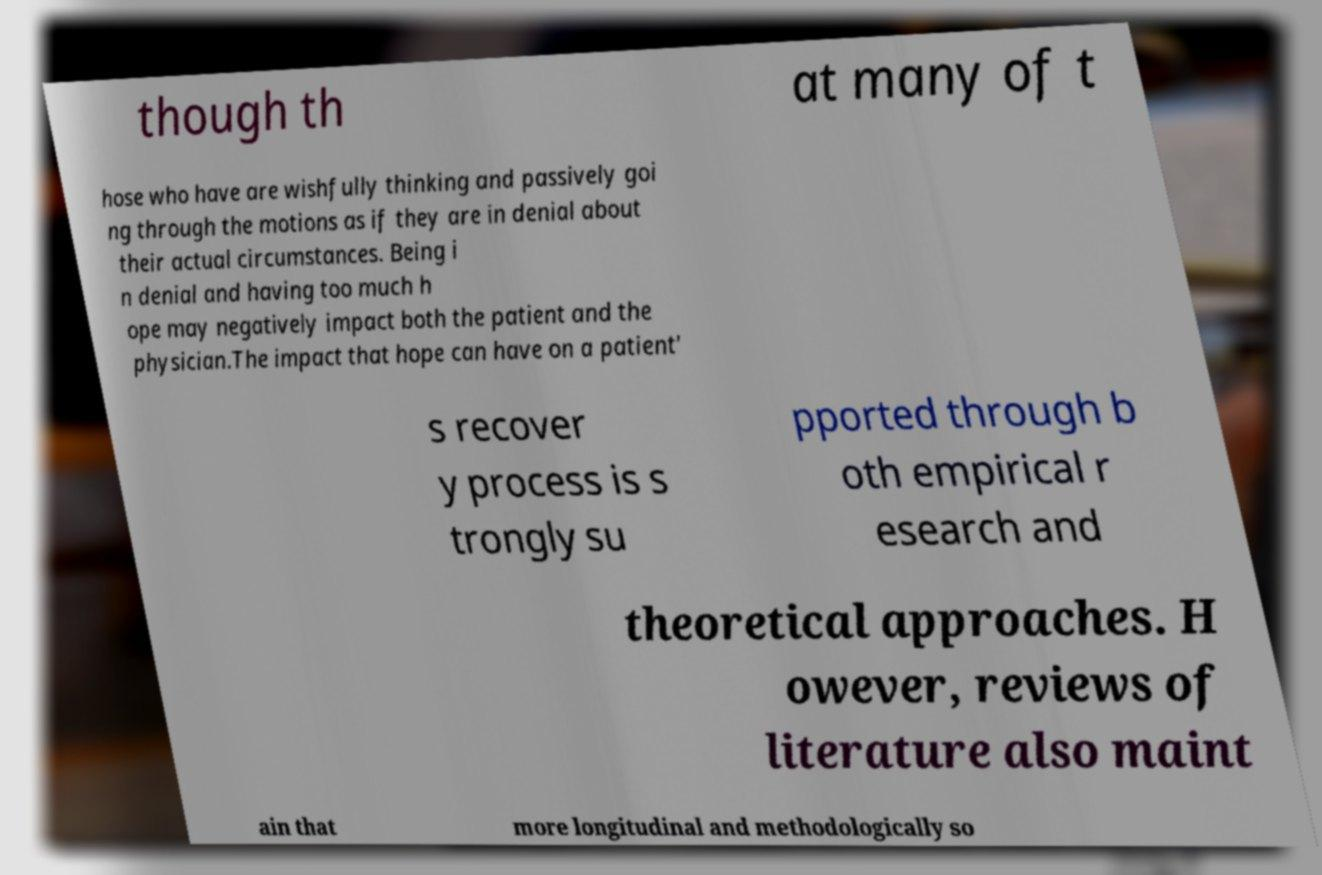What messages or text are displayed in this image? I need them in a readable, typed format. though th at many of t hose who have are wishfully thinking and passively goi ng through the motions as if they are in denial about their actual circumstances. Being i n denial and having too much h ope may negatively impact both the patient and the physician.The impact that hope can have on a patient' s recover y process is s trongly su pported through b oth empirical r esearch and theoretical approaches. H owever, reviews of literature also maint ain that more longitudinal and methodologically so 